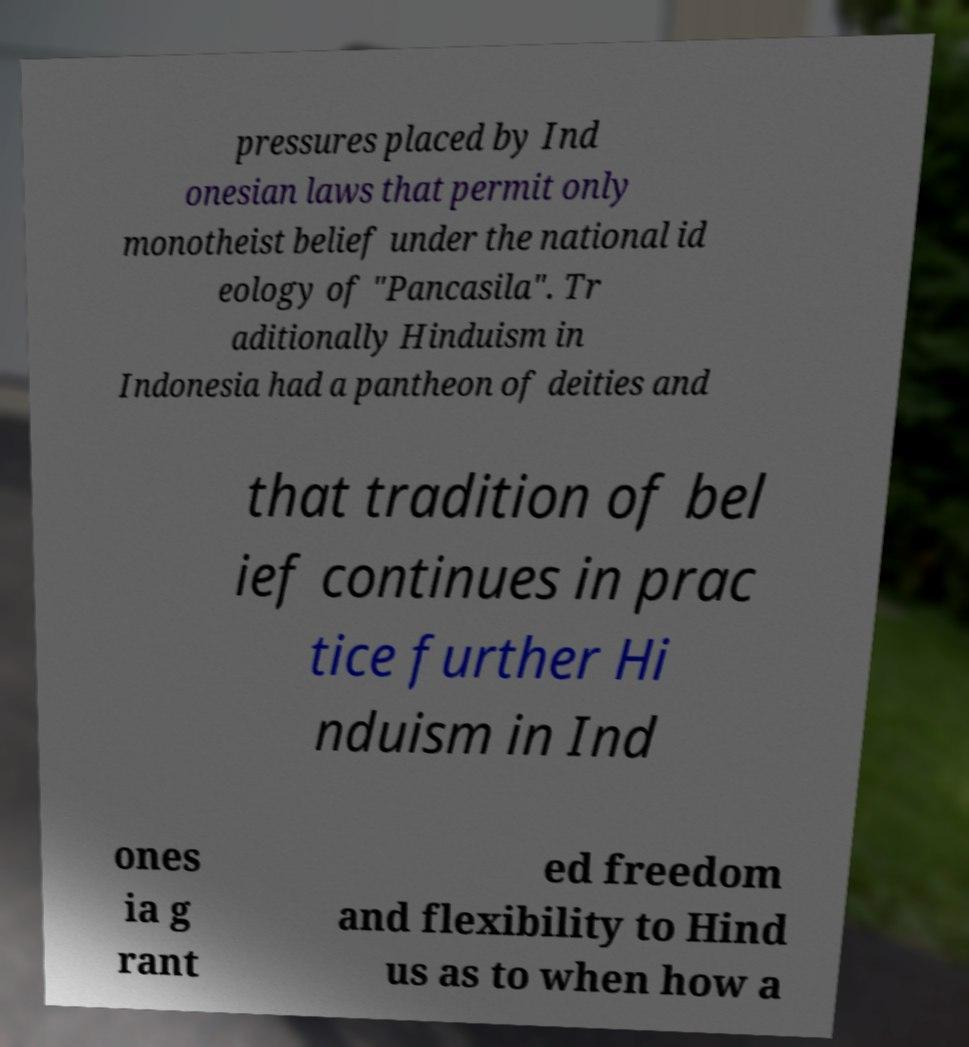What messages or text are displayed in this image? I need them in a readable, typed format. pressures placed by Ind onesian laws that permit only monotheist belief under the national id eology of "Pancasila". Tr aditionally Hinduism in Indonesia had a pantheon of deities and that tradition of bel ief continues in prac tice further Hi nduism in Ind ones ia g rant ed freedom and flexibility to Hind us as to when how a 